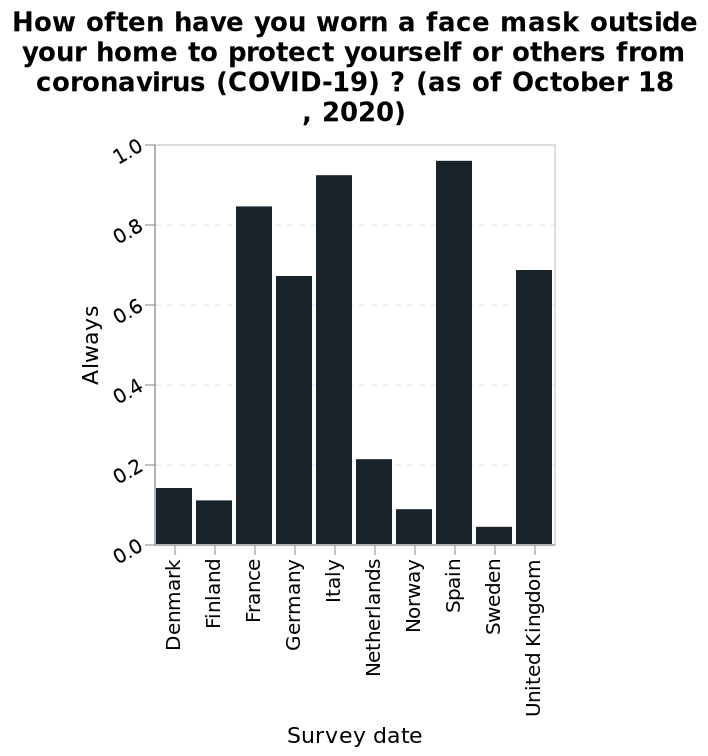<image>
What is the time period covered by the data represented in the bar chart?  The data represented in the bar chart is as of October 18, 2020, indicating the frequency of wearing face masks outside the home up until that date. How does the mask-wearing in the Scandinavian countries compare to that of mid-European countries?  The Scandinavian countries have worn masks far less compared to mid-European countries, except for the Netherlands. Describe the following image in detail Here a bar chart is named How often have you worn a face mask outside your home to protect yourself or others from coronavirus (COVID-19) ? (as of October 18 , 2020). The y-axis measures Always using linear scale of range 0.0 to 1.0 while the x-axis shows Survey date as categorical scale starting with Denmark and ending with United Kingdom. How many categories are there on the x-axis of the bar chart? There are multiple categories on the x-axis of the bar chart, representing different survey dates from Denmark to the United Kingdom. 